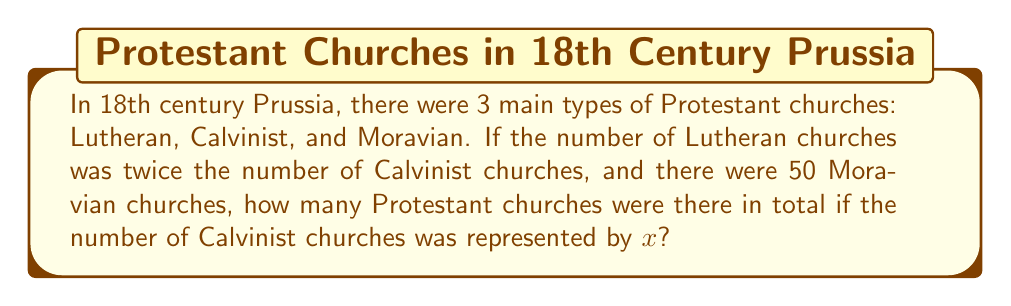Show me your answer to this math problem. Let's approach this step-by-step:

1) Let $x$ represent the number of Calvinist churches.

2) The number of Lutheran churches is twice that of Calvinist churches, so it's $2x$.

3) We're given that there are 50 Moravian churches.

4) To find the total number of Protestant churches, we sum these three types:

   $\text{Total} = \text{Calvinist} + \text{Lutheran} + \text{Moravian}$
   $\text{Total} = x + 2x + 50$

5) Simplifying:
   $\text{Total} = 3x + 50$

This expression represents the total number of Protestant churches in 18th century Prussia in terms of $x$, where $x$ is the number of Calvinist churches.
Answer: $3x + 50$ 